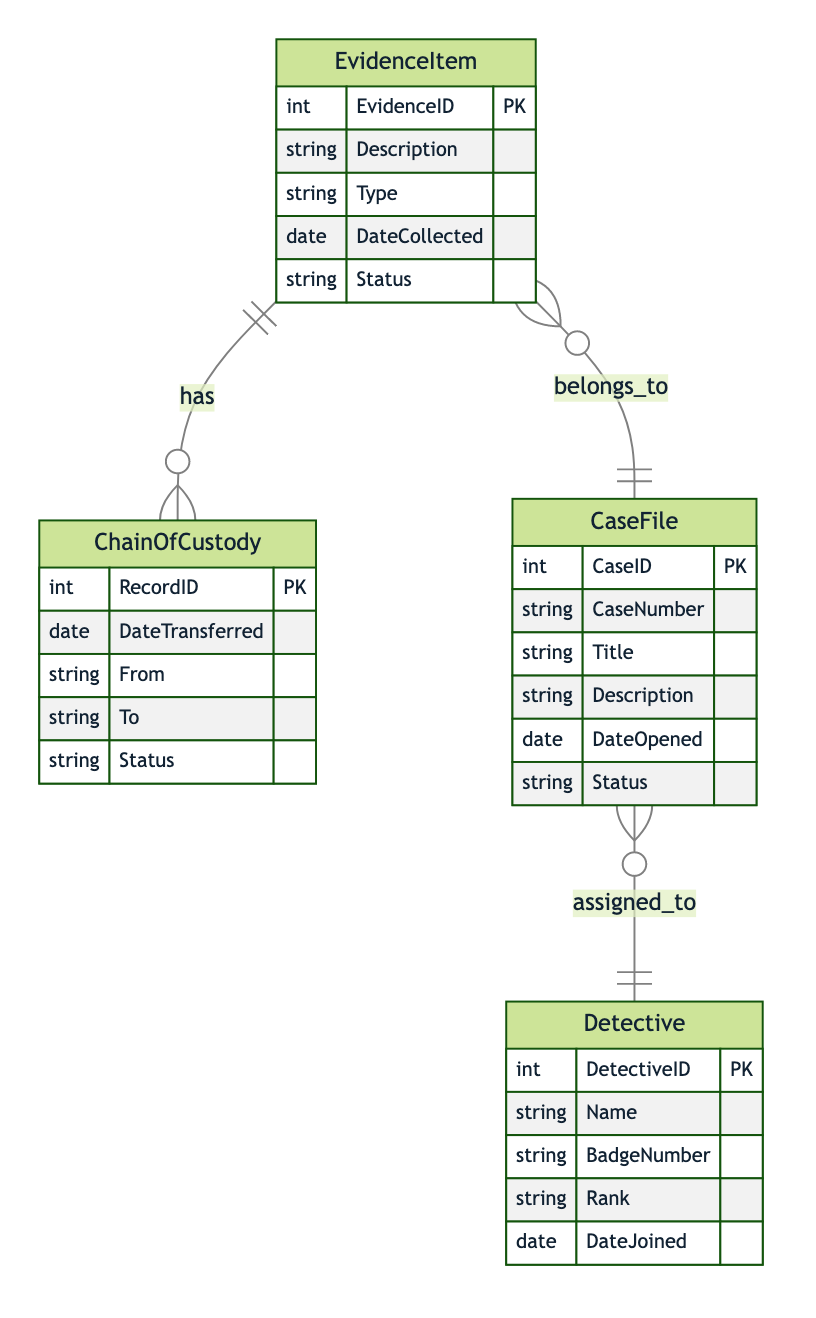What is the primary key of the EvidenceItem entity? The primary key for the EvidenceItem is marked as EvidenceID. The diagram indicates that EvidenceID serves as the unique identifier for this entity.
Answer: EvidenceID How many attributes does the CaseFile entity have? In the diagram, the CaseFile entity displays a total of six attributes: CaseID, CaseNumber, Title, Description, DateOpened, and Status. Thus, we can count these attributes to determine the total.
Answer: six What is the relationship type between the EvidenceItem and CaseFile entities? The diagram shows that EvidenceItem has a relationship with CaseFile represented by "belongs_to," which indicates a Many-to-One relationship type. By examining the lines connecting these two entities, we confirm this relationship type.
Answer: Many-to-One Which entity has a One-to-Many relationship with the Detective entity? According to the diagram, the Detective entity has a One-to-Many relationship with the CaseFile entity, as it indicates that one detective can be assigned to multiple case files. Moving through the relationships, we identify CaseFile as having this connection.
Answer: CaseFile What is the primary key of the ChainOfCustody entity? The diagram indicates that the primary key for the ChainOfCustody entity is RecordID, which uniquely identifies each record in this entity. Following the notations for primary keys in the diagram confirms this.
Answer: RecordID How many entities are there in the diagram? By counting the entities illustrated in the diagram, we find four entities: EvidenceItem, CaseFile, Detective, and ChainOfCustody. Each one is explicitly defined, allowing for straightforward counting.
Answer: four What is the status field in the EvidenceItem entity used for? The status field in the EvidenceItem entity generally indicates the current condition or state of the evidence item, as described in the diagram’s attribute list. By interpreting this field's role, we understand it reflects evidence management details.
Answer: current condition Who is assigned to the case files, based on the diagram? The diagram shows that it is the Detective entity that is assigned to the case files. By following the link between CaseFile and Detective, we conclude that detectives handle or oversee the case files.
Answer: Detective 